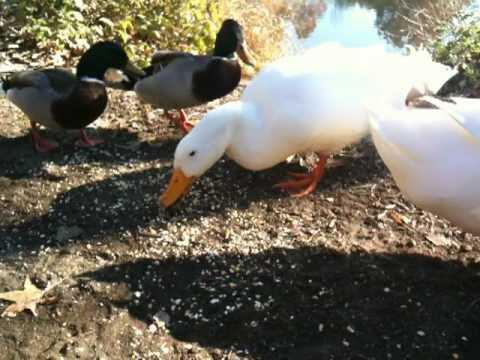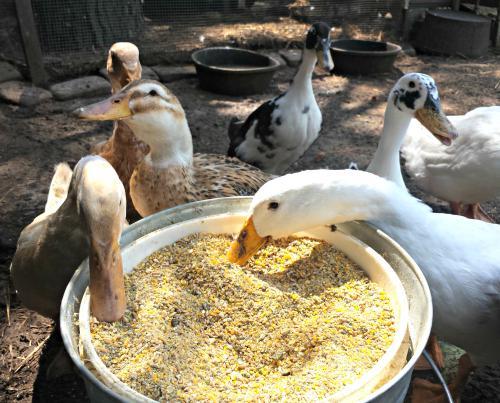The first image is the image on the left, the second image is the image on the right. Analyze the images presented: Is the assertion "One image shows black-necked Canadian geese standing in shallow water, and the other image includes a white duck eating something." valid? Answer yes or no. No. The first image is the image on the left, the second image is the image on the right. Assess this claim about the two images: "An image contains no more than one white duck.". Correct or not? Answer yes or no. No. 